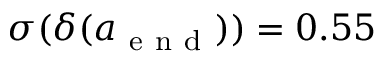<formula> <loc_0><loc_0><loc_500><loc_500>\sigma ( \delta ( a _ { e n d } ) ) = 0 . 5 5</formula> 